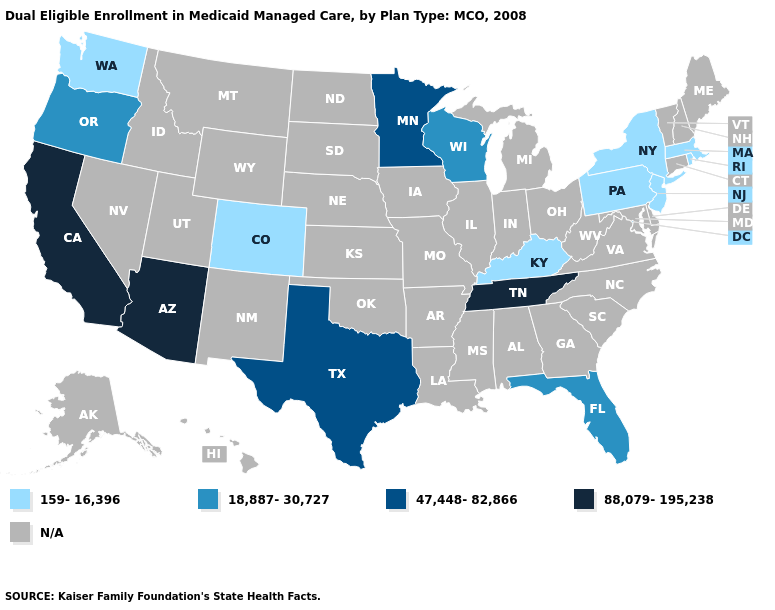Does the first symbol in the legend represent the smallest category?
Be succinct. Yes. Name the states that have a value in the range 47,448-82,866?
Short answer required. Minnesota, Texas. Name the states that have a value in the range 47,448-82,866?
Concise answer only. Minnesota, Texas. Does the first symbol in the legend represent the smallest category?
Short answer required. Yes. What is the value of New York?
Keep it brief. 159-16,396. What is the value of New Mexico?
Quick response, please. N/A. What is the lowest value in states that border Maryland?
Write a very short answer. 159-16,396. Does Washington have the highest value in the West?
Write a very short answer. No. Which states have the lowest value in the South?
Answer briefly. Kentucky. What is the lowest value in the USA?
Answer briefly. 159-16,396. Name the states that have a value in the range N/A?
Write a very short answer. Alabama, Alaska, Arkansas, Connecticut, Delaware, Georgia, Hawaii, Idaho, Illinois, Indiana, Iowa, Kansas, Louisiana, Maine, Maryland, Michigan, Mississippi, Missouri, Montana, Nebraska, Nevada, New Hampshire, New Mexico, North Carolina, North Dakota, Ohio, Oklahoma, South Carolina, South Dakota, Utah, Vermont, Virginia, West Virginia, Wyoming. What is the highest value in the South ?
Give a very brief answer. 88,079-195,238. What is the value of Connecticut?
Write a very short answer. N/A. 